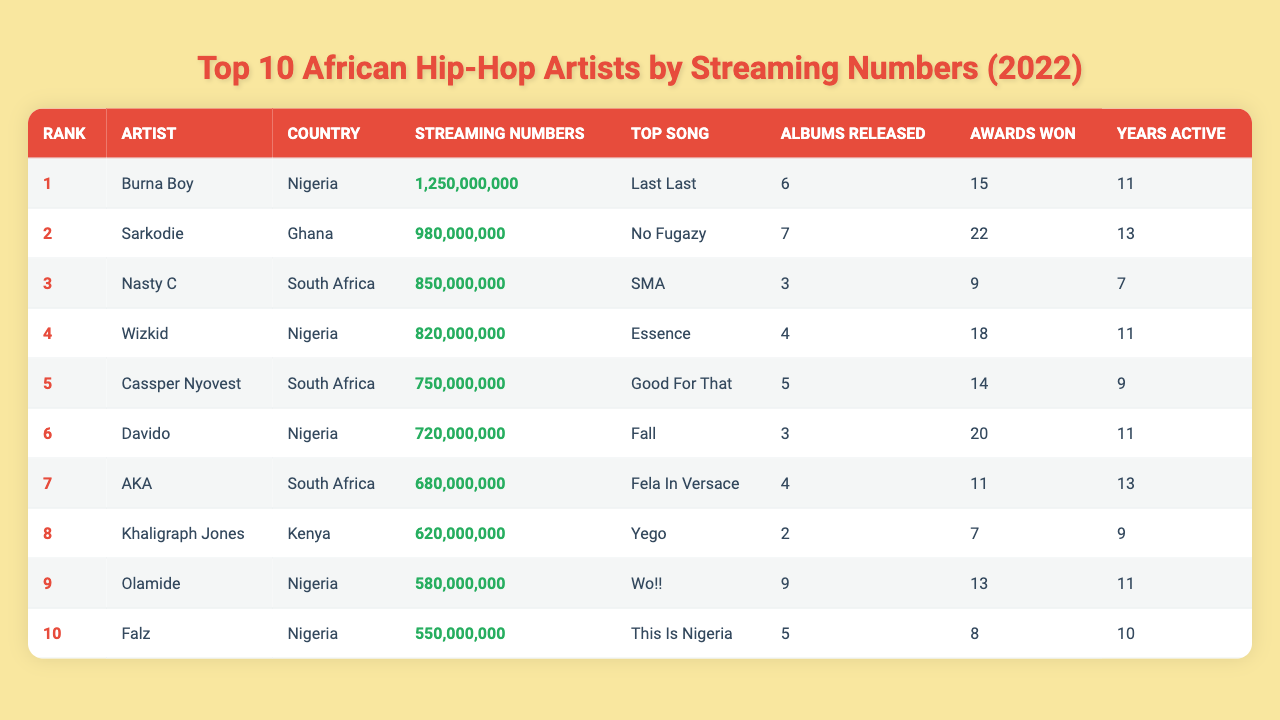What is the streaming number for Burna Boy? According to the table, Burna Boy's streaming number is listed as 1,250,000,000.
Answer: 1,250,000,000 Who is the top artist from Ghana? The table shows that Sarkodie is the top artist from Ghana with a streaming number of 980,000,000.
Answer: Sarkodie How many awards has Nasty C won? The table states that Nasty C has won 9 awards.
Answer: 9 What is the total number of albums released by the top 3 artists? Adding the albums released by the top 3 artists: 6 (Burna Boy) + 7 (Sarkodie) + 3 (Nasty C) = 16.
Answer: 16 Which artist has the highest number of awards won? Sarkodie has the highest number of awards won with a total of 22.
Answer: Sarkodie Is Wizkid from Nigeria? The table confirms that Wizkid is from Nigeria.
Answer: Yes What is the difference in streaming numbers between Burna Boy and Cassper Nyovest? Burna Boy has 1,250,000,000 and Cassper Nyovest has 750,000,000, so the difference is 1,250,000,000 - 750,000,000 = 500,000,000.
Answer: 500,000,000 Which country has the most artists in the top 10? By examining the table, Nigeria has 4 artists (Burna Boy, Wizkid, Davido, Olamide), while South Africa and Ghana have 3 and 2, respectively, thus Nigeria has the most artists.
Answer: Nigeria What is the average number of years active for the top 5 artists? The years active for the top 5 artists are 11 (Burna Boy) + 13 (Sarkodie) + 7 (Nasty C) + 11 (Wizkid) + 9 (Cassper Nyovest) = 51; dividing by 5 gives us an average of 51/5 = 10.2.
Answer: 10.2 Which artist has the top song titled "Wo!!"? The table specifies that Olamide has the top song titled "Wo!!".
Answer: Olamide Has AKA released more albums than Khaligraph Jones? According to the table, AKA has released 4 albums, while Khaligraph Jones has released 2, hence AKA has released more albums.
Answer: Yes 